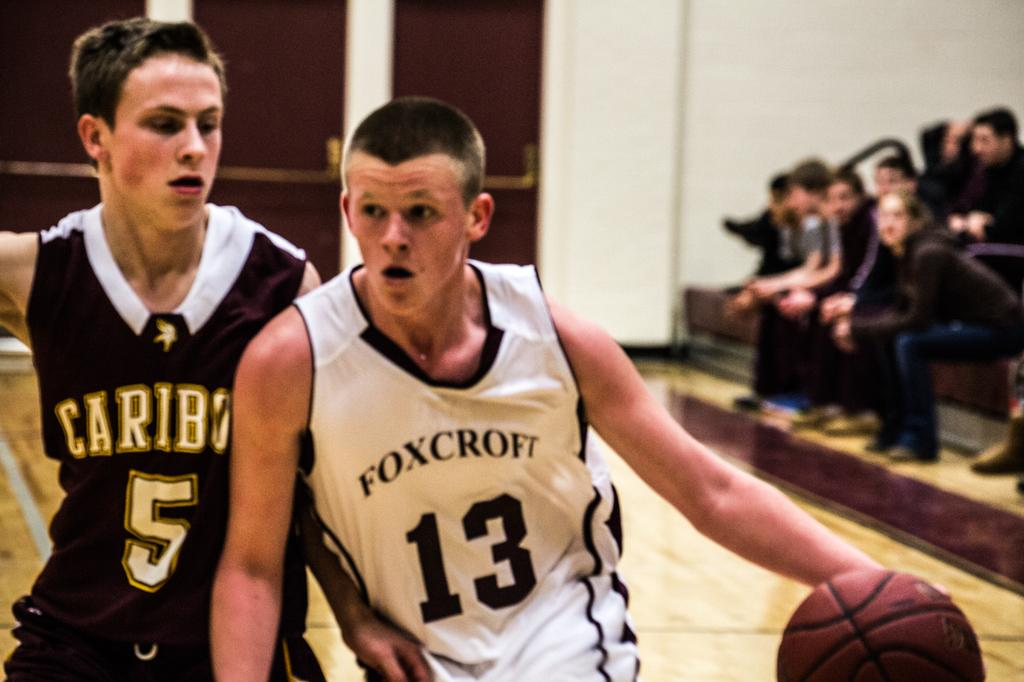<image>
Relay a brief, clear account of the picture shown. A basketball game is underway and the player with the ball has Foxcroft on his jersey. 